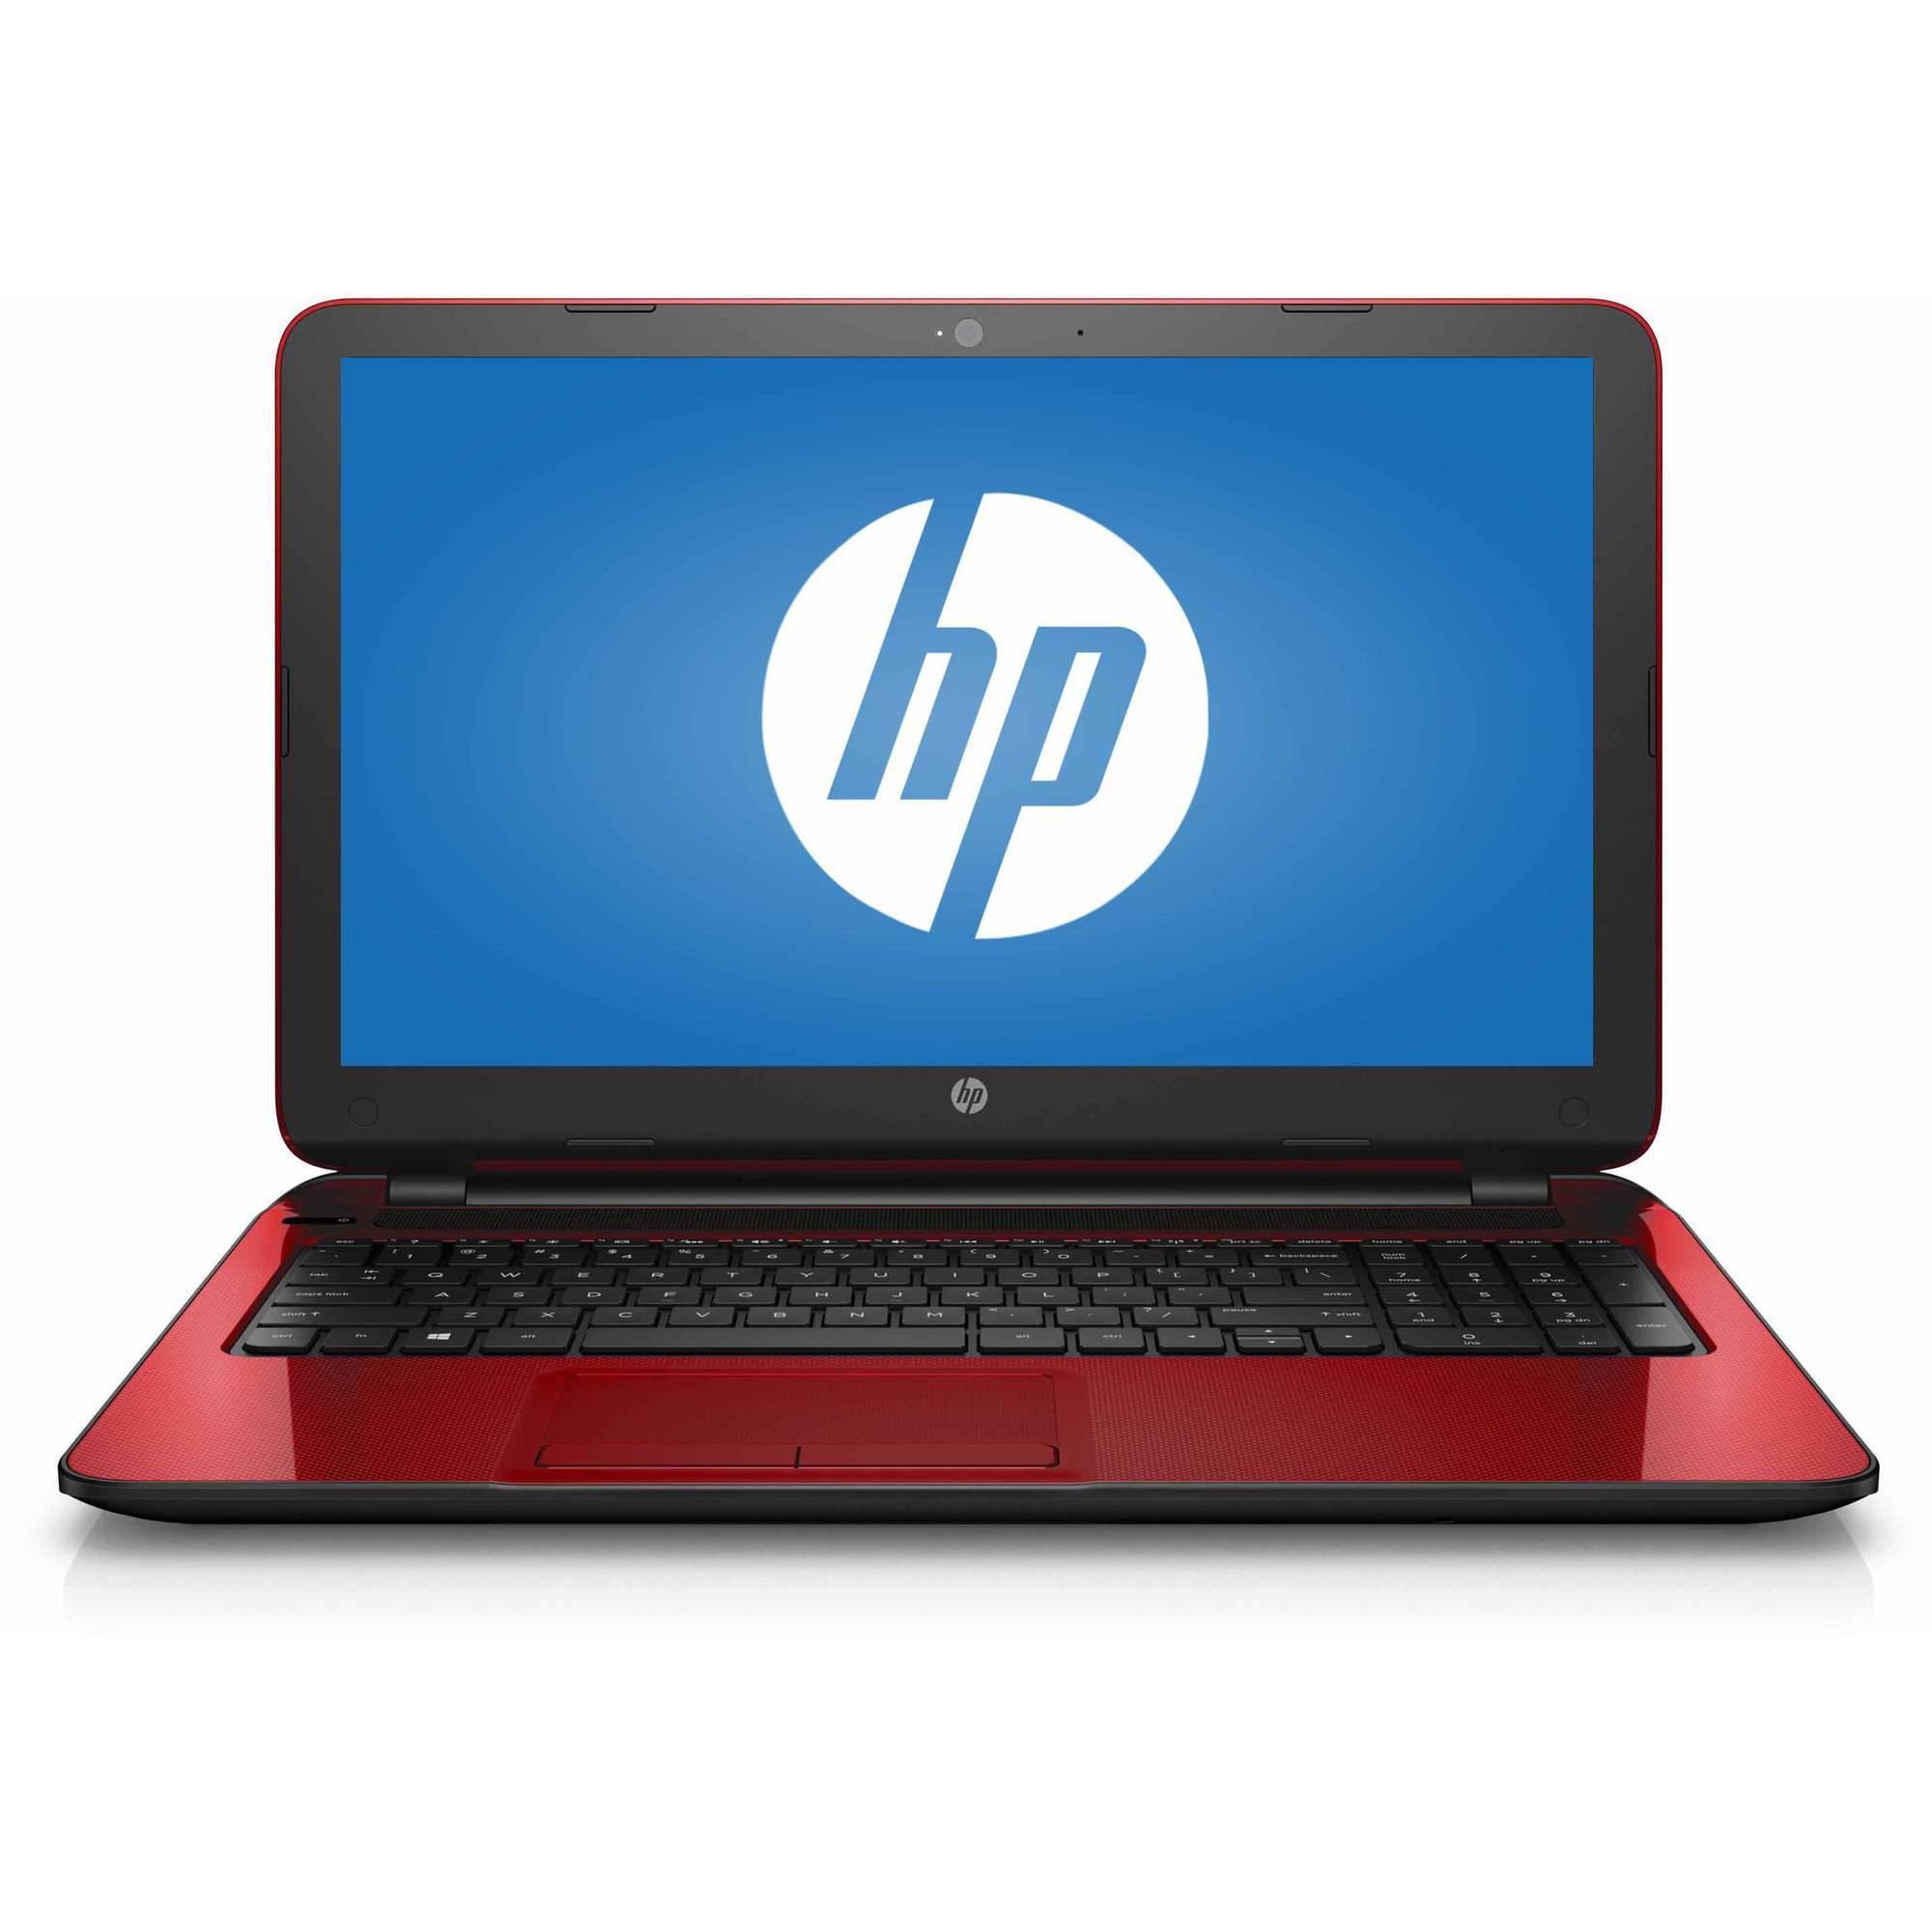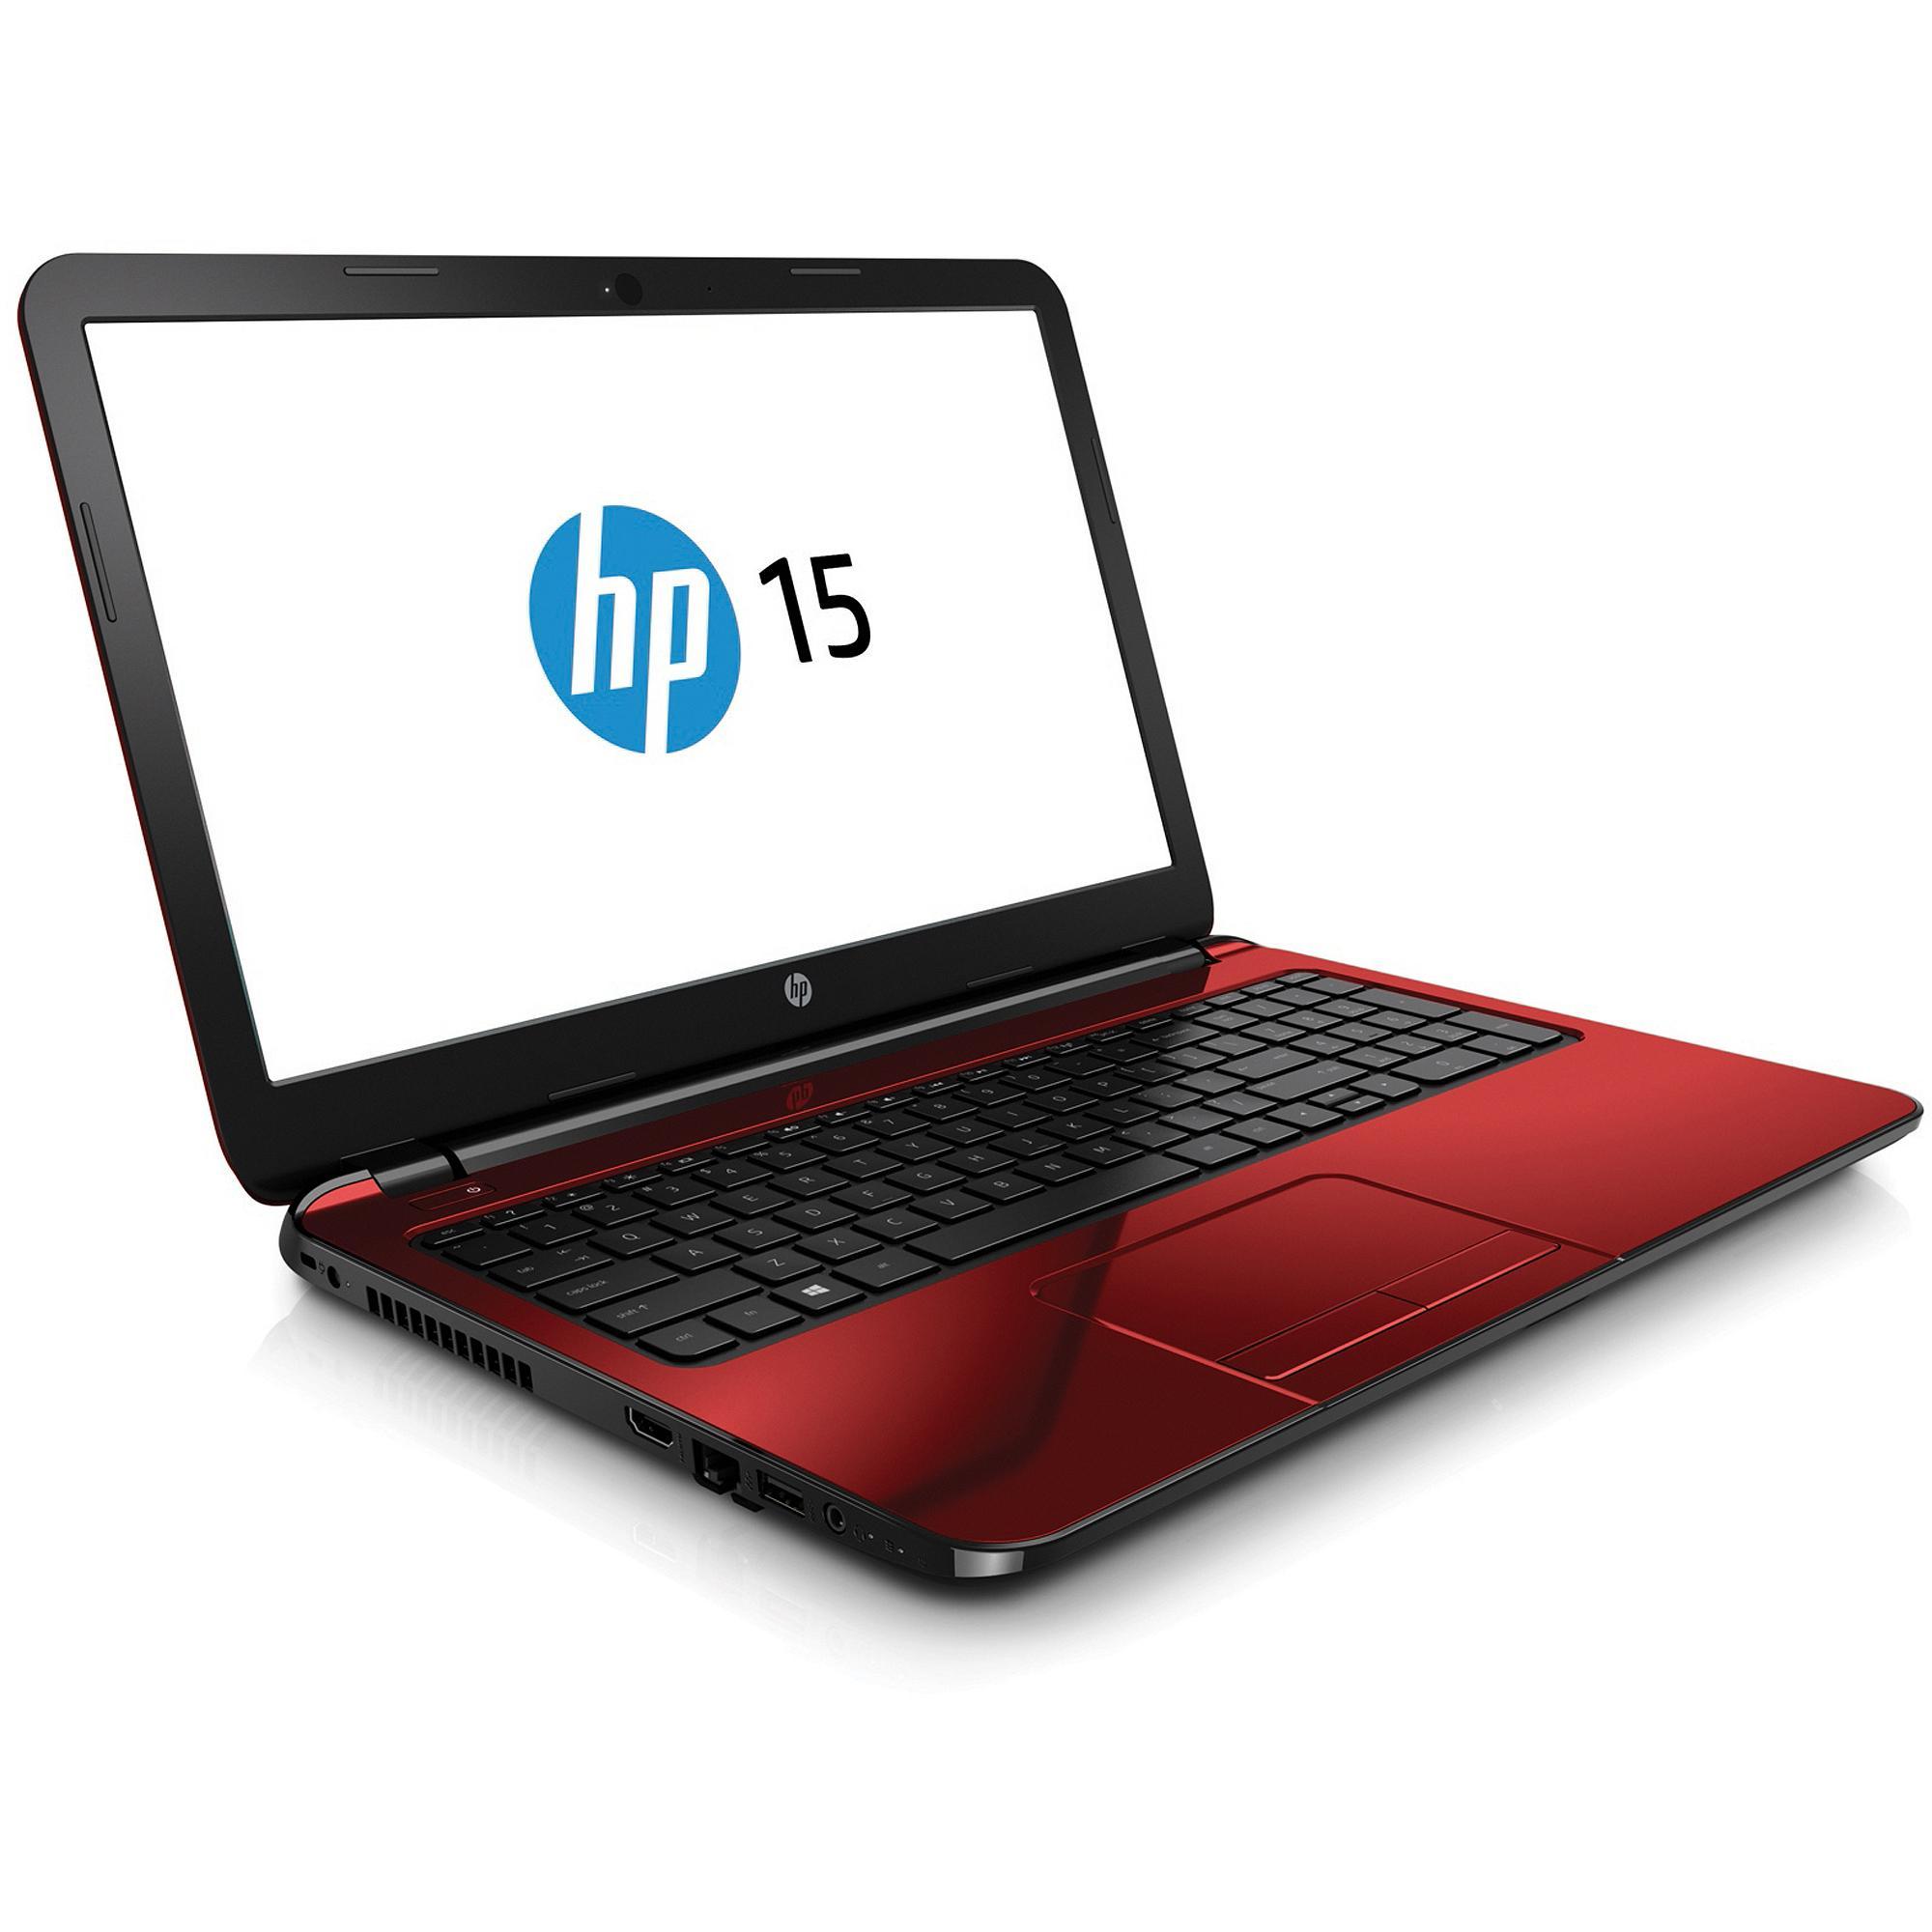The first image is the image on the left, the second image is the image on the right. For the images shown, is this caption "The full back of the red laptop is being shown." true? Answer yes or no. No. The first image is the image on the left, the second image is the image on the right. Assess this claim about the two images: "One of the laptops is turned so the screen is visible, and the other is turned so that the screen is not visible.". Correct or not? Answer yes or no. No. 